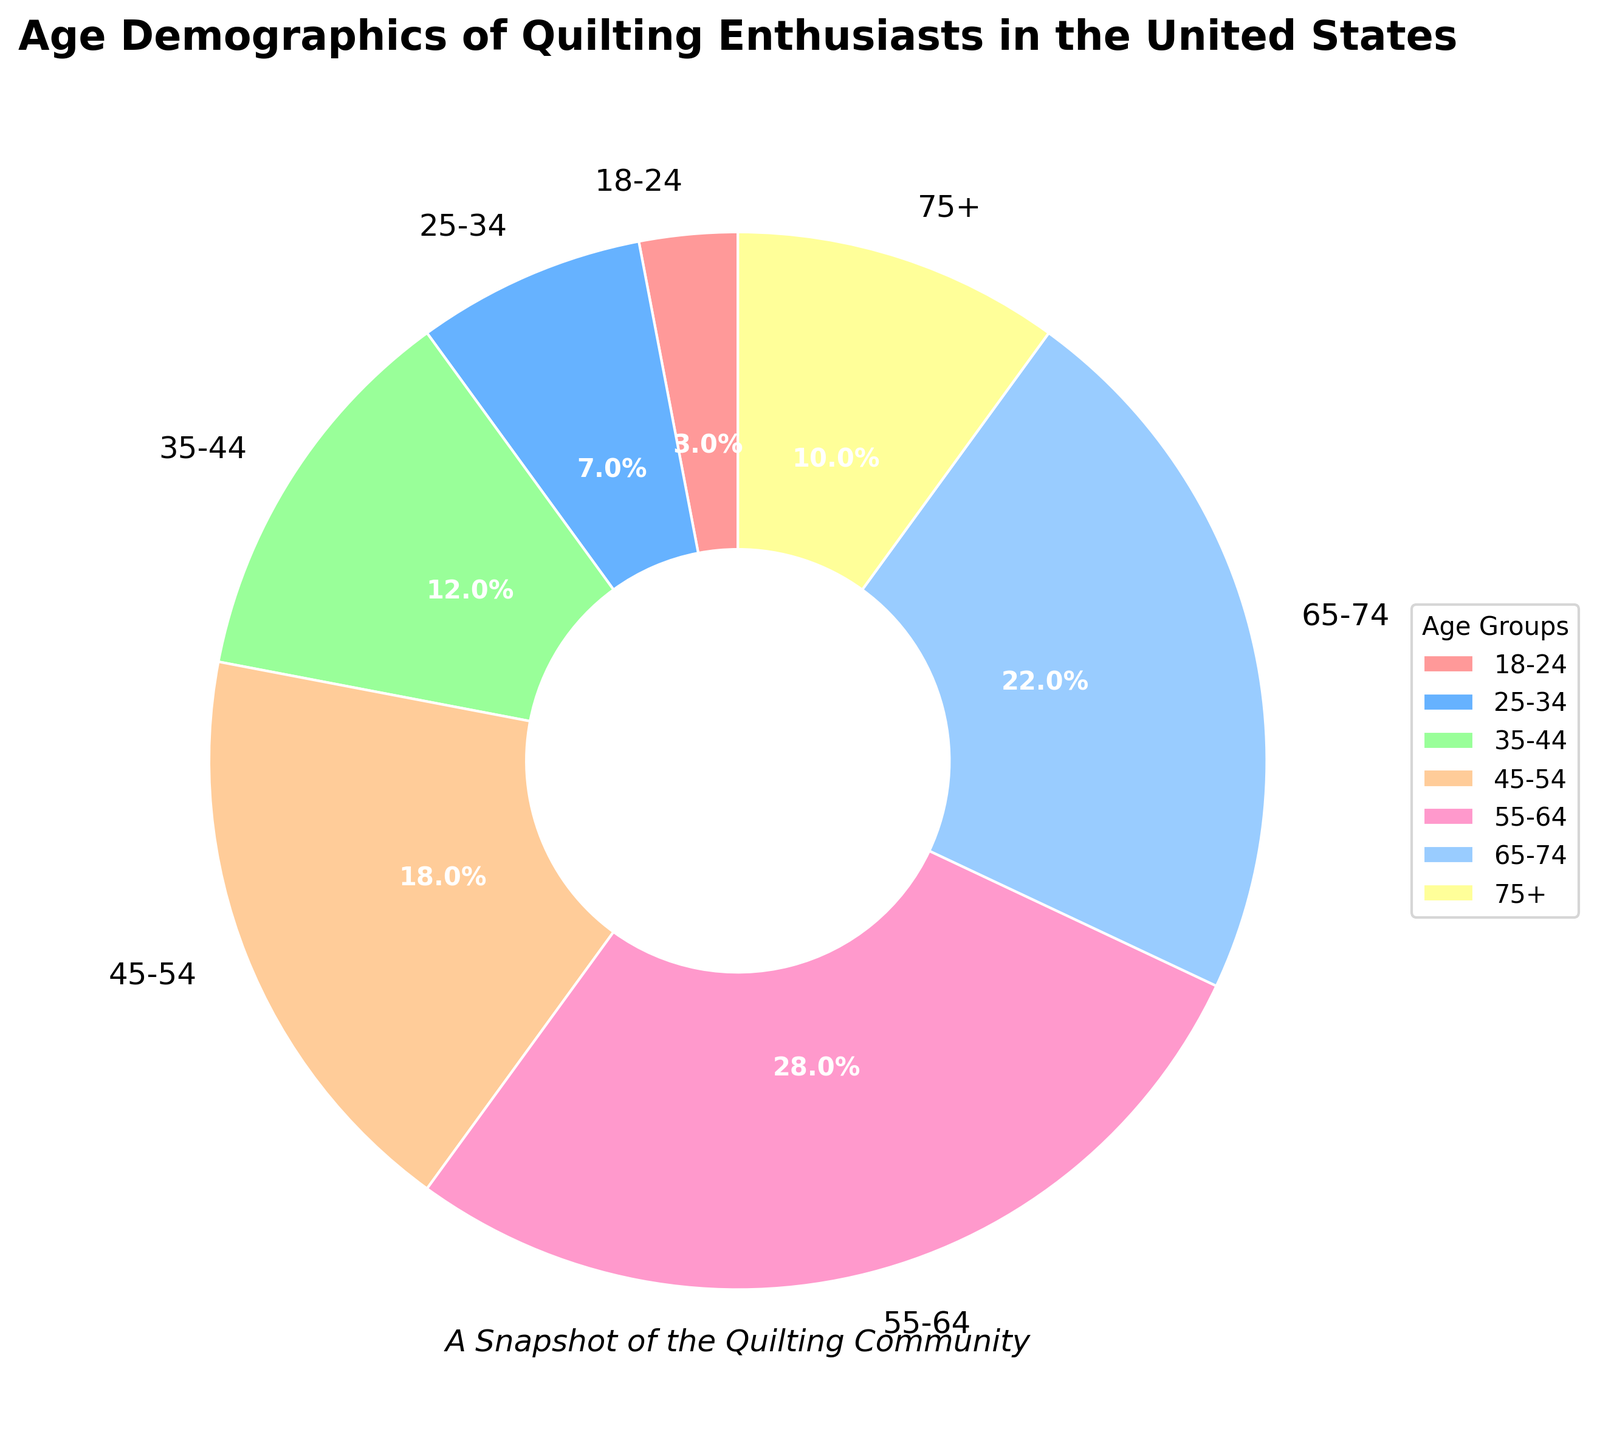What is the largest age group among quilting enthusiasts? The largest segment of the pie chart is labeled with its corresponding percentage. Here, the 55-64 age group occupies the largest portion at 28%.
Answer: 55-64 Which age group has a smaller percentage than the 18-24 group? Looking at the pie chart, the 18-24 group has a percentage of 3%. All other age groups have a higher percentage, and there isn't an age group with a smaller percentage.
Answer: None What is the combined percentage of quilting enthusiasts aged 65 and above? The groups aged 65-74 and 75+ need to be combined. Summing their percentages: 22% (65-74) + 10% (75+) = 32%.
Answer: 32% How does the percentage of quilting enthusiasts aged 45-54 compare to those aged 35-44? The percentage of the 45-54 age group is 18%, while the 35-44 age group has 12%. Comparing these, the 45-54 age group is larger.
Answer: 18% is larger What percentage of quilting enthusiasts are under 35 years old? Add the percentages of the 18-24 and 25-34 age groups: 3% + 7% = 10%.
Answer: 10% Which color represents the 55-64 age group on the pie chart? By matching colors to age groups: light pink color represents the 55-64 age group.
Answer: Light pink What is the difference in percentage between the age groups 55-64 and 65-74? Subtract the percentage of the 65-74 group from the 55-64 group: 28% - 22% = 6%.
Answer: 6% What is the average percentage of quilting enthusiasts in the age groups 18-24, 25-34, and 35-44? Sum the percentages of these groups and divide by 3. (3% + 7% + 12%) / 3 = 22% / 3 ≈ 7.33%.
Answer: 7.33% What age group represents the smallest wedge in the pie chart? The smallest triangular wedge in the pie chart has the 18-24 label with a percentage of 3%, making it the smallest group visually.
Answer: 18-24 If you add the percentage of the two smallest age groups, what is the result? First, identify the two smallest age groups, which are 18-24 (3%) and 25-34 (7%). Adding them, 3% + 7% = 10%.
Answer: 10% 